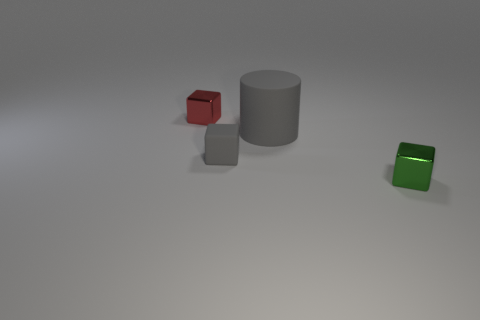What is the color of the rubber block that is the same size as the red metal object?
Keep it short and to the point. Gray. What number of cylinders are tiny gray matte things or tiny green things?
Make the answer very short. 0. Does the green shiny thing have the same shape as the gray matte thing that is right of the gray matte cube?
Provide a succinct answer. No. What number of green metallic things are the same size as the matte cylinder?
Your response must be concise. 0. Is the shape of the gray thing to the right of the tiny rubber thing the same as the thing behind the big object?
Provide a short and direct response. No. The tiny object that is the same color as the matte cylinder is what shape?
Offer a very short reply. Cube. What color is the tiny shiny block behind the metallic object that is in front of the red thing?
Your answer should be very brief. Red. What is the color of the tiny rubber object that is the same shape as the small red metallic object?
Your response must be concise. Gray. Are there any other things that have the same material as the tiny green cube?
Keep it short and to the point. Yes. What is the size of the other shiny object that is the same shape as the red thing?
Provide a succinct answer. Small. 